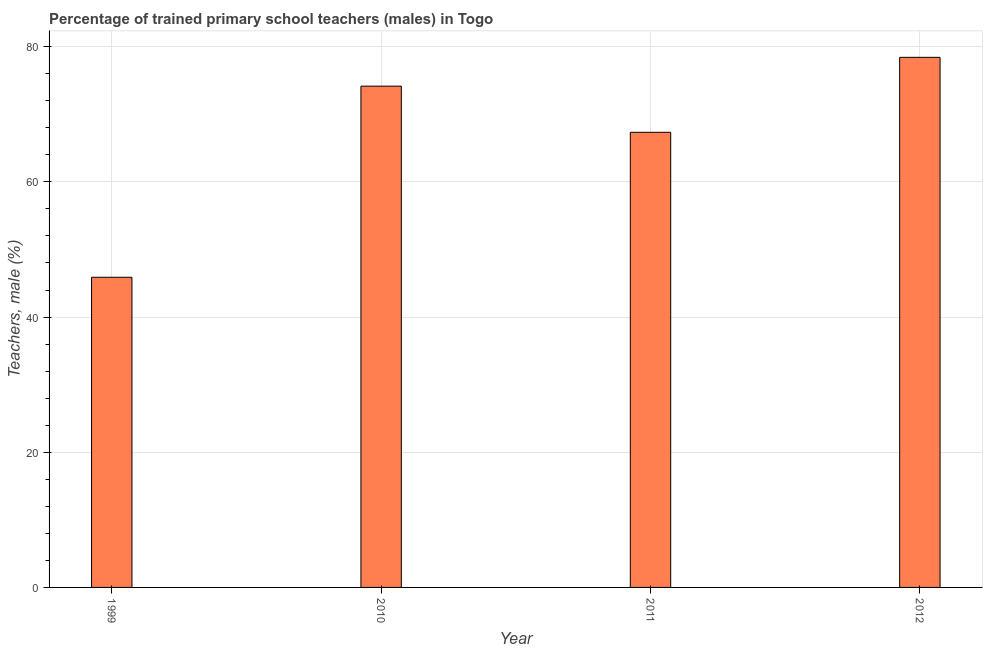Does the graph contain any zero values?
Your answer should be compact. No. Does the graph contain grids?
Ensure brevity in your answer.  Yes. What is the title of the graph?
Your answer should be compact. Percentage of trained primary school teachers (males) in Togo. What is the label or title of the X-axis?
Your answer should be very brief. Year. What is the label or title of the Y-axis?
Offer a very short reply. Teachers, male (%). What is the percentage of trained male teachers in 1999?
Offer a very short reply. 45.88. Across all years, what is the maximum percentage of trained male teachers?
Make the answer very short. 78.42. Across all years, what is the minimum percentage of trained male teachers?
Your answer should be compact. 45.88. In which year was the percentage of trained male teachers minimum?
Provide a short and direct response. 1999. What is the sum of the percentage of trained male teachers?
Keep it short and to the point. 265.8. What is the difference between the percentage of trained male teachers in 1999 and 2012?
Your answer should be very brief. -32.54. What is the average percentage of trained male teachers per year?
Make the answer very short. 66.45. What is the median percentage of trained male teachers?
Keep it short and to the point. 70.75. What is the ratio of the percentage of trained male teachers in 2010 to that in 2011?
Provide a succinct answer. 1.1. What is the difference between the highest and the second highest percentage of trained male teachers?
Keep it short and to the point. 4.26. What is the difference between the highest and the lowest percentage of trained male teachers?
Provide a short and direct response. 32.54. In how many years, is the percentage of trained male teachers greater than the average percentage of trained male teachers taken over all years?
Your answer should be very brief. 3. How many bars are there?
Keep it short and to the point. 4. What is the difference between two consecutive major ticks on the Y-axis?
Ensure brevity in your answer.  20. Are the values on the major ticks of Y-axis written in scientific E-notation?
Make the answer very short. No. What is the Teachers, male (%) of 1999?
Offer a very short reply. 45.88. What is the Teachers, male (%) in 2010?
Make the answer very short. 74.16. What is the Teachers, male (%) in 2011?
Provide a short and direct response. 67.33. What is the Teachers, male (%) in 2012?
Ensure brevity in your answer.  78.42. What is the difference between the Teachers, male (%) in 1999 and 2010?
Make the answer very short. -28.28. What is the difference between the Teachers, male (%) in 1999 and 2011?
Keep it short and to the point. -21.45. What is the difference between the Teachers, male (%) in 1999 and 2012?
Keep it short and to the point. -32.54. What is the difference between the Teachers, male (%) in 2010 and 2011?
Your response must be concise. 6.83. What is the difference between the Teachers, male (%) in 2010 and 2012?
Your answer should be very brief. -4.26. What is the difference between the Teachers, male (%) in 2011 and 2012?
Your answer should be very brief. -11.09. What is the ratio of the Teachers, male (%) in 1999 to that in 2010?
Offer a terse response. 0.62. What is the ratio of the Teachers, male (%) in 1999 to that in 2011?
Give a very brief answer. 0.68. What is the ratio of the Teachers, male (%) in 1999 to that in 2012?
Offer a very short reply. 0.58. What is the ratio of the Teachers, male (%) in 2010 to that in 2011?
Your answer should be compact. 1.1. What is the ratio of the Teachers, male (%) in 2010 to that in 2012?
Ensure brevity in your answer.  0.95. What is the ratio of the Teachers, male (%) in 2011 to that in 2012?
Provide a succinct answer. 0.86. 